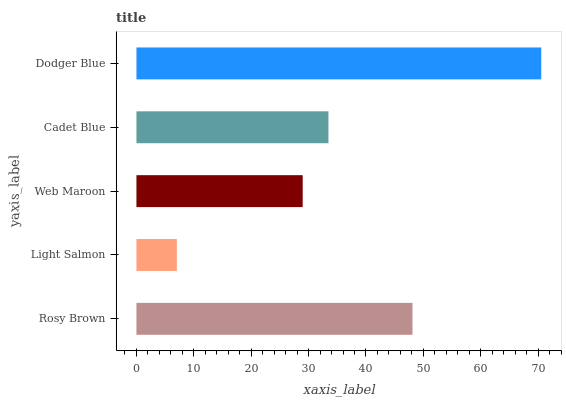Is Light Salmon the minimum?
Answer yes or no. Yes. Is Dodger Blue the maximum?
Answer yes or no. Yes. Is Web Maroon the minimum?
Answer yes or no. No. Is Web Maroon the maximum?
Answer yes or no. No. Is Web Maroon greater than Light Salmon?
Answer yes or no. Yes. Is Light Salmon less than Web Maroon?
Answer yes or no. Yes. Is Light Salmon greater than Web Maroon?
Answer yes or no. No. Is Web Maroon less than Light Salmon?
Answer yes or no. No. Is Cadet Blue the high median?
Answer yes or no. Yes. Is Cadet Blue the low median?
Answer yes or no. Yes. Is Web Maroon the high median?
Answer yes or no. No. Is Web Maroon the low median?
Answer yes or no. No. 